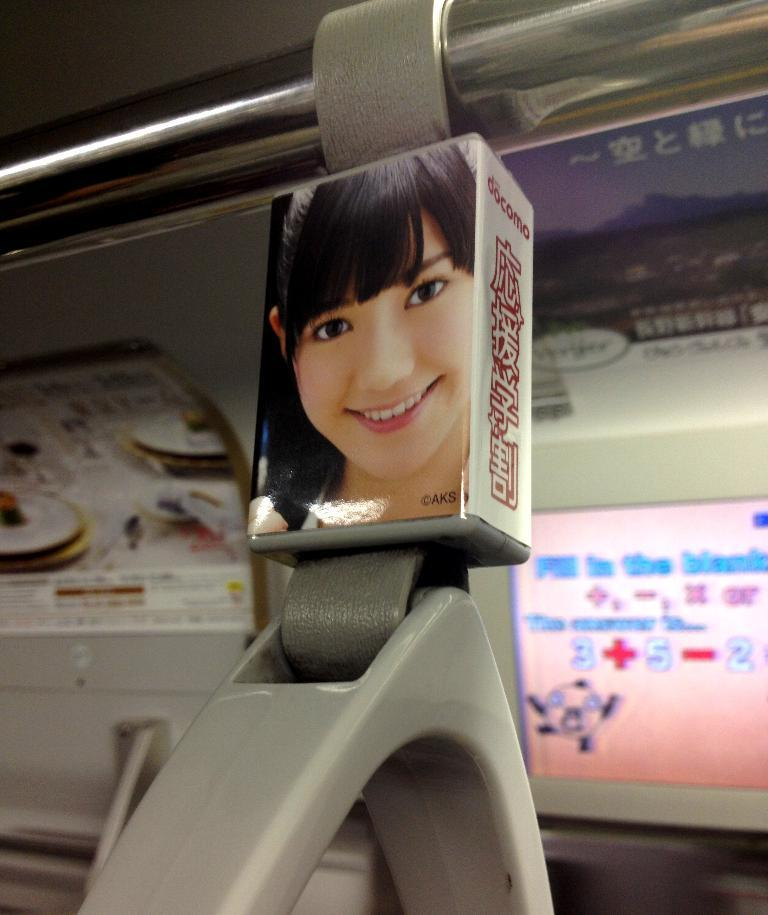What is featured on the posters in the image? The posters contain text, numbers, symbols, and figures. Can you describe the content of the posters in more detail? The posters contain a combination of text, numbers, symbols, and figures, but the specific details cannot be determined from the image alone. What else can be seen in the image besides the posters? There is a rod and other objects in the image. How many kittens are playing with the root in the image? There are no kittens or roots present in the image. What type of walk is depicted in the image? There is no walk depicted in the image; it features posters, a rod, and other objects. 